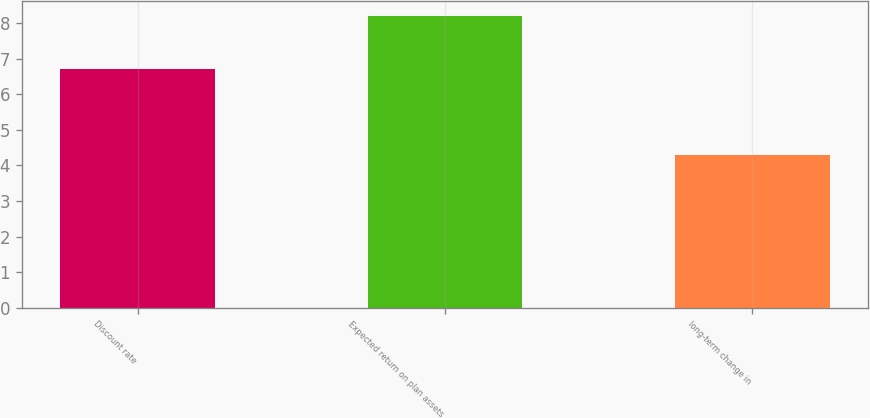Convert chart to OTSL. <chart><loc_0><loc_0><loc_500><loc_500><bar_chart><fcel>Discount rate<fcel>Expected return on plan assets<fcel>long-term change in<nl><fcel>6.7<fcel>8.2<fcel>4.3<nl></chart> 